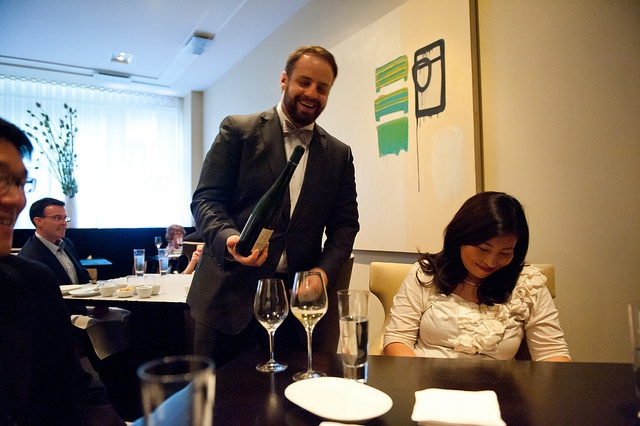Describe the objects in this image and their specific colors. I can see people in gray, black, maroon, and brown tones, dining table in gray, black, ivory, and maroon tones, people in gray, black, tan, and maroon tones, people in gray, black, maroon, and brown tones, and cup in gray, black, and maroon tones in this image. 